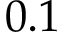Convert formula to latex. <formula><loc_0><loc_0><loc_500><loc_500>0 . 1</formula> 